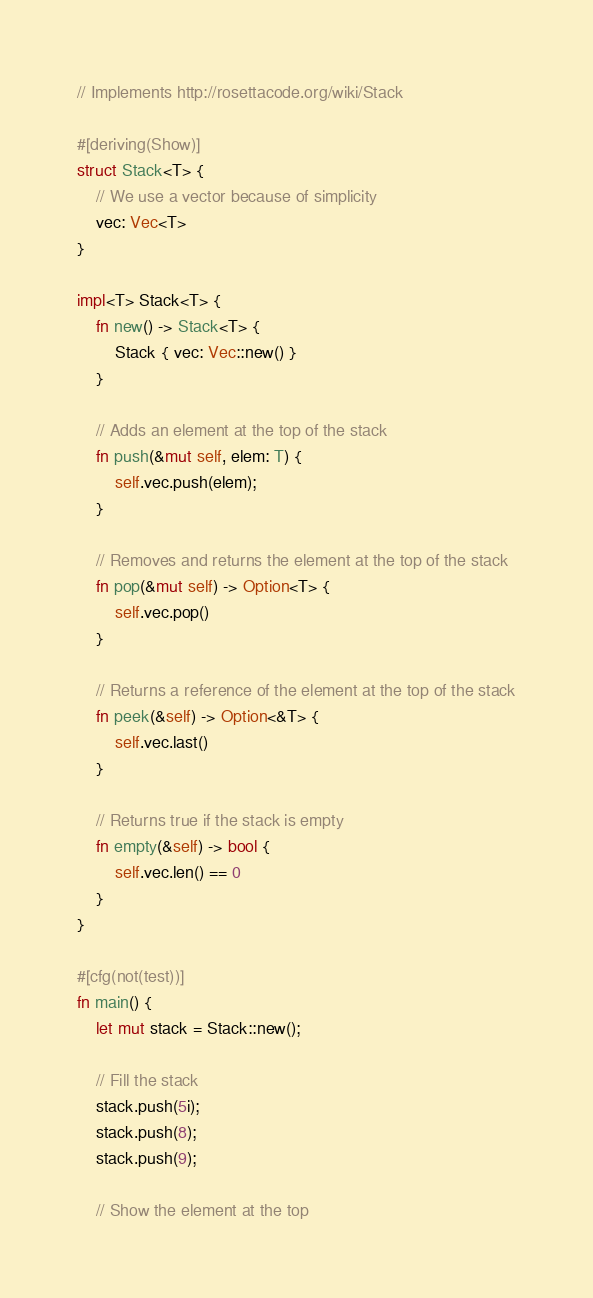<code> <loc_0><loc_0><loc_500><loc_500><_Rust_>// Implements http://rosettacode.org/wiki/Stack

#[deriving(Show)]
struct Stack<T> {
    // We use a vector because of simplicity
    vec: Vec<T>
}

impl<T> Stack<T> {
    fn new() -> Stack<T> {
        Stack { vec: Vec::new() }
    }

    // Adds an element at the top of the stack
    fn push(&mut self, elem: T) {
        self.vec.push(elem);
    }

    // Removes and returns the element at the top of the stack
    fn pop(&mut self) -> Option<T> {
        self.vec.pop()
    }

    // Returns a reference of the element at the top of the stack
    fn peek(&self) -> Option<&T> {
        self.vec.last()
    }

    // Returns true if the stack is empty
    fn empty(&self) -> bool {
        self.vec.len() == 0
    }
}

#[cfg(not(test))]
fn main() {
    let mut stack = Stack::new();

    // Fill the stack
    stack.push(5i);
    stack.push(8);
    stack.push(9);

    // Show the element at the top</code> 